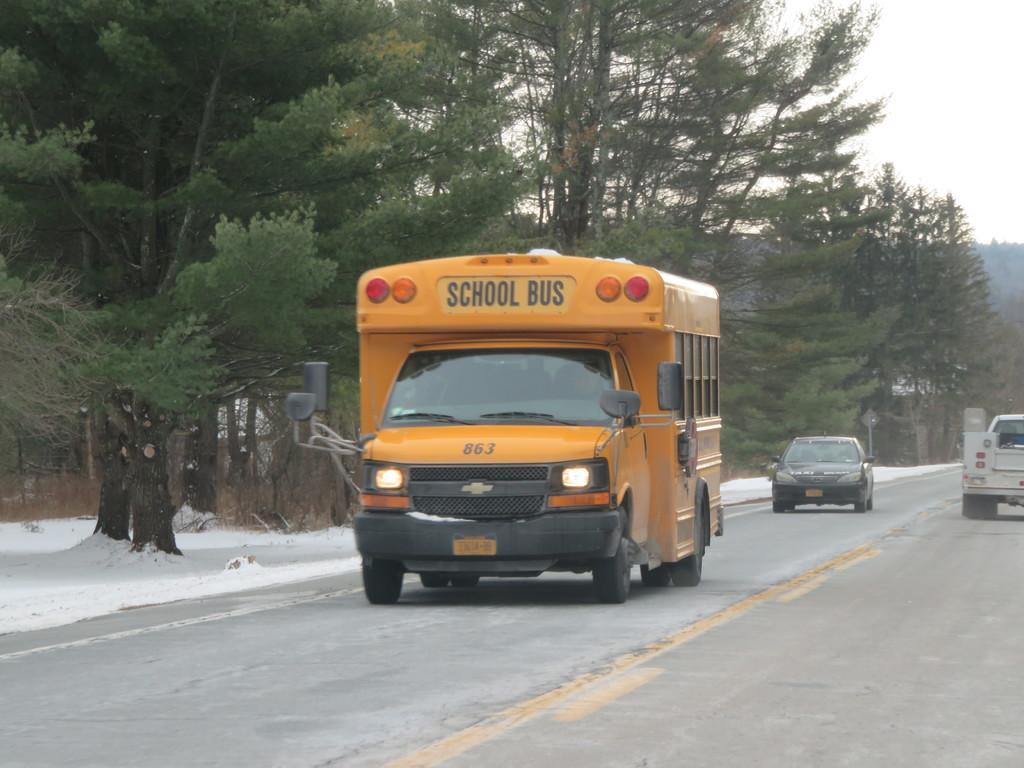Where was the image taken? The image was taken outside a city. What can be seen in the foreground of the image? There is a road in the foreground of the image. What vehicles are moving on the road? Trucks and a car are moving on the road. What can be seen in the background of the image? There are trees and snow in the background of the image. How would you describe the sky in the image? The sky is cloudy in the image. Can you tell me what type of doctor is standing near the car in the image? There is no doctor present in the image; it features a road with trucks and a car moving on it, along with trees, snow, and a cloudy sky in the background. 